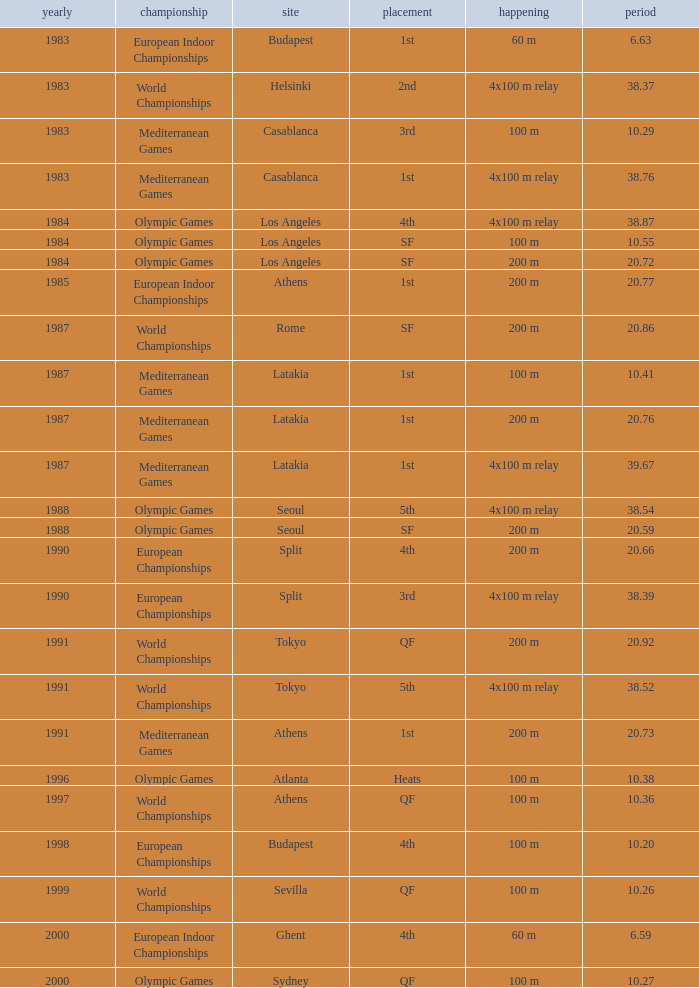What Venue has a Year smaller than 1991, Time larger than 10.29, Competition of mediterranean games, and Event of 4x100 m relay? Casablanca, Latakia. Could you help me parse every detail presented in this table? {'header': ['yearly', 'championship', 'site', 'placement', 'happening', 'period'], 'rows': [['1983', 'European Indoor Championships', 'Budapest', '1st', '60 m', '6.63'], ['1983', 'World Championships', 'Helsinki', '2nd', '4x100 m relay', '38.37'], ['1983', 'Mediterranean Games', 'Casablanca', '3rd', '100 m', '10.29'], ['1983', 'Mediterranean Games', 'Casablanca', '1st', '4x100 m relay', '38.76'], ['1984', 'Olympic Games', 'Los Angeles', '4th', '4x100 m relay', '38.87'], ['1984', 'Olympic Games', 'Los Angeles', 'SF', '100 m', '10.55'], ['1984', 'Olympic Games', 'Los Angeles', 'SF', '200 m', '20.72'], ['1985', 'European Indoor Championships', 'Athens', '1st', '200 m', '20.77'], ['1987', 'World Championships', 'Rome', 'SF', '200 m', '20.86'], ['1987', 'Mediterranean Games', 'Latakia', '1st', '100 m', '10.41'], ['1987', 'Mediterranean Games', 'Latakia', '1st', '200 m', '20.76'], ['1987', 'Mediterranean Games', 'Latakia', '1st', '4x100 m relay', '39.67'], ['1988', 'Olympic Games', 'Seoul', '5th', '4x100 m relay', '38.54'], ['1988', 'Olympic Games', 'Seoul', 'SF', '200 m', '20.59'], ['1990', 'European Championships', 'Split', '4th', '200 m', '20.66'], ['1990', 'European Championships', 'Split', '3rd', '4x100 m relay', '38.39'], ['1991', 'World Championships', 'Tokyo', 'QF', '200 m', '20.92'], ['1991', 'World Championships', 'Tokyo', '5th', '4x100 m relay', '38.52'], ['1991', 'Mediterranean Games', 'Athens', '1st', '200 m', '20.73'], ['1996', 'Olympic Games', 'Atlanta', 'Heats', '100 m', '10.38'], ['1997', 'World Championships', 'Athens', 'QF', '100 m', '10.36'], ['1998', 'European Championships', 'Budapest', '4th', '100 m', '10.20'], ['1999', 'World Championships', 'Sevilla', 'QF', '100 m', '10.26'], ['2000', 'European Indoor Championships', 'Ghent', '4th', '60 m', '6.59'], ['2000', 'Olympic Games', 'Sydney', 'QF', '100 m', '10.27']]} 